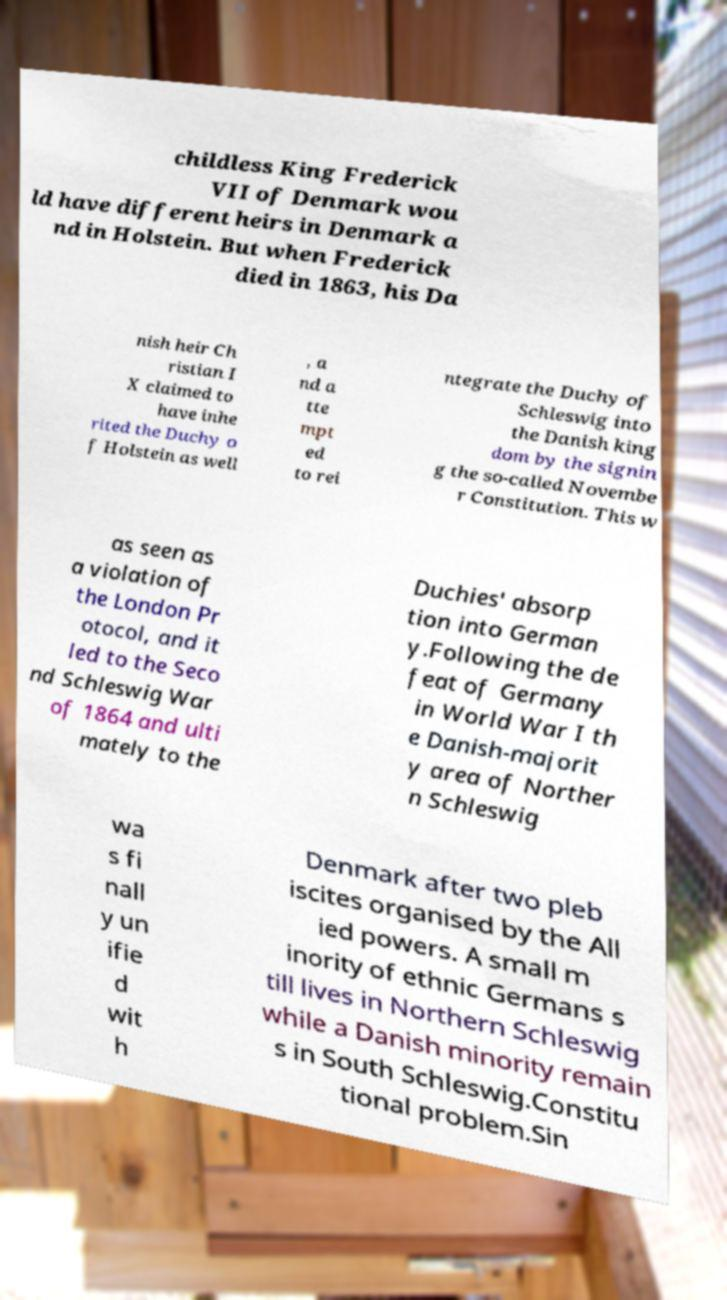What messages or text are displayed in this image? I need them in a readable, typed format. childless King Frederick VII of Denmark wou ld have different heirs in Denmark a nd in Holstein. But when Frederick died in 1863, his Da nish heir Ch ristian I X claimed to have inhe rited the Duchy o f Holstein as well , a nd a tte mpt ed to rei ntegrate the Duchy of Schleswig into the Danish king dom by the signin g the so-called Novembe r Constitution. This w as seen as a violation of the London Pr otocol, and it led to the Seco nd Schleswig War of 1864 and ulti mately to the Duchies' absorp tion into German y.Following the de feat of Germany in World War I th e Danish-majorit y area of Norther n Schleswig wa s fi nall y un ifie d wit h Denmark after two pleb iscites organised by the All ied powers. A small m inority of ethnic Germans s till lives in Northern Schleswig while a Danish minority remain s in South Schleswig.Constitu tional problem.Sin 